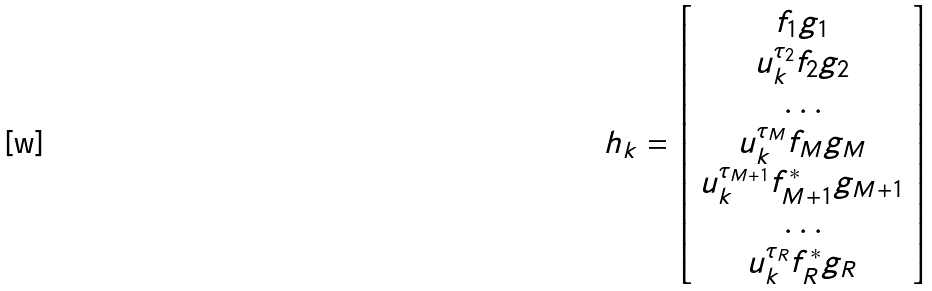Convert formula to latex. <formula><loc_0><loc_0><loc_500><loc_500>h _ { k } = \left [ \begin{array} { c } f _ { 1 } g _ { 1 } \\ u _ { k } ^ { \tau _ { 2 } } f _ { 2 } g _ { 2 } \\ \dots \\ u _ { k } ^ { \tau _ { M } } f _ { M } g _ { M } \\ u _ { k } ^ { \tau _ { M + 1 } } f _ { M + 1 } ^ { * } g _ { M + 1 } \\ \dots \\ u _ { k } ^ { \tau _ { R } } f _ { R } ^ { * } g _ { R } \end{array} \right ]</formula> 